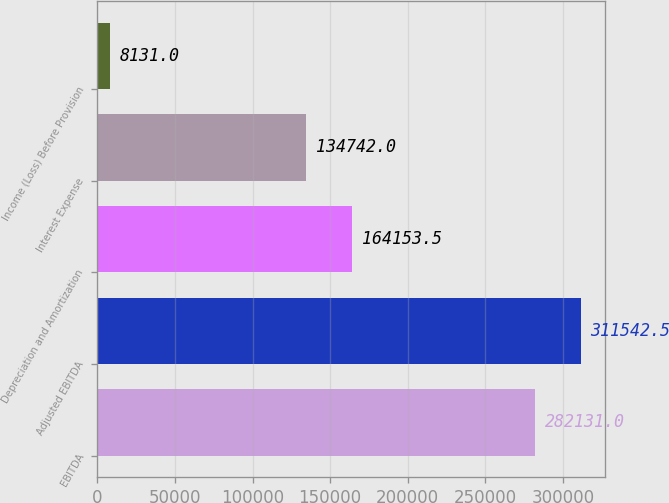Convert chart to OTSL. <chart><loc_0><loc_0><loc_500><loc_500><bar_chart><fcel>EBITDA<fcel>Adjusted EBITDA<fcel>Depreciation and Amortization<fcel>Interest Expense<fcel>Income (Loss) Before Provision<nl><fcel>282131<fcel>311542<fcel>164154<fcel>134742<fcel>8131<nl></chart> 